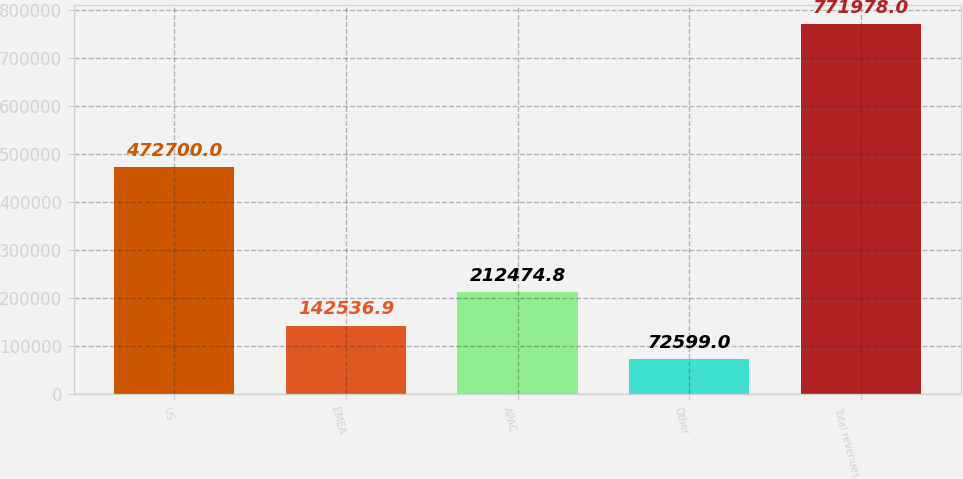<chart> <loc_0><loc_0><loc_500><loc_500><bar_chart><fcel>US<fcel>EMEA<fcel>APAC<fcel>Other<fcel>Total revenues<nl><fcel>472700<fcel>142537<fcel>212475<fcel>72599<fcel>771978<nl></chart> 